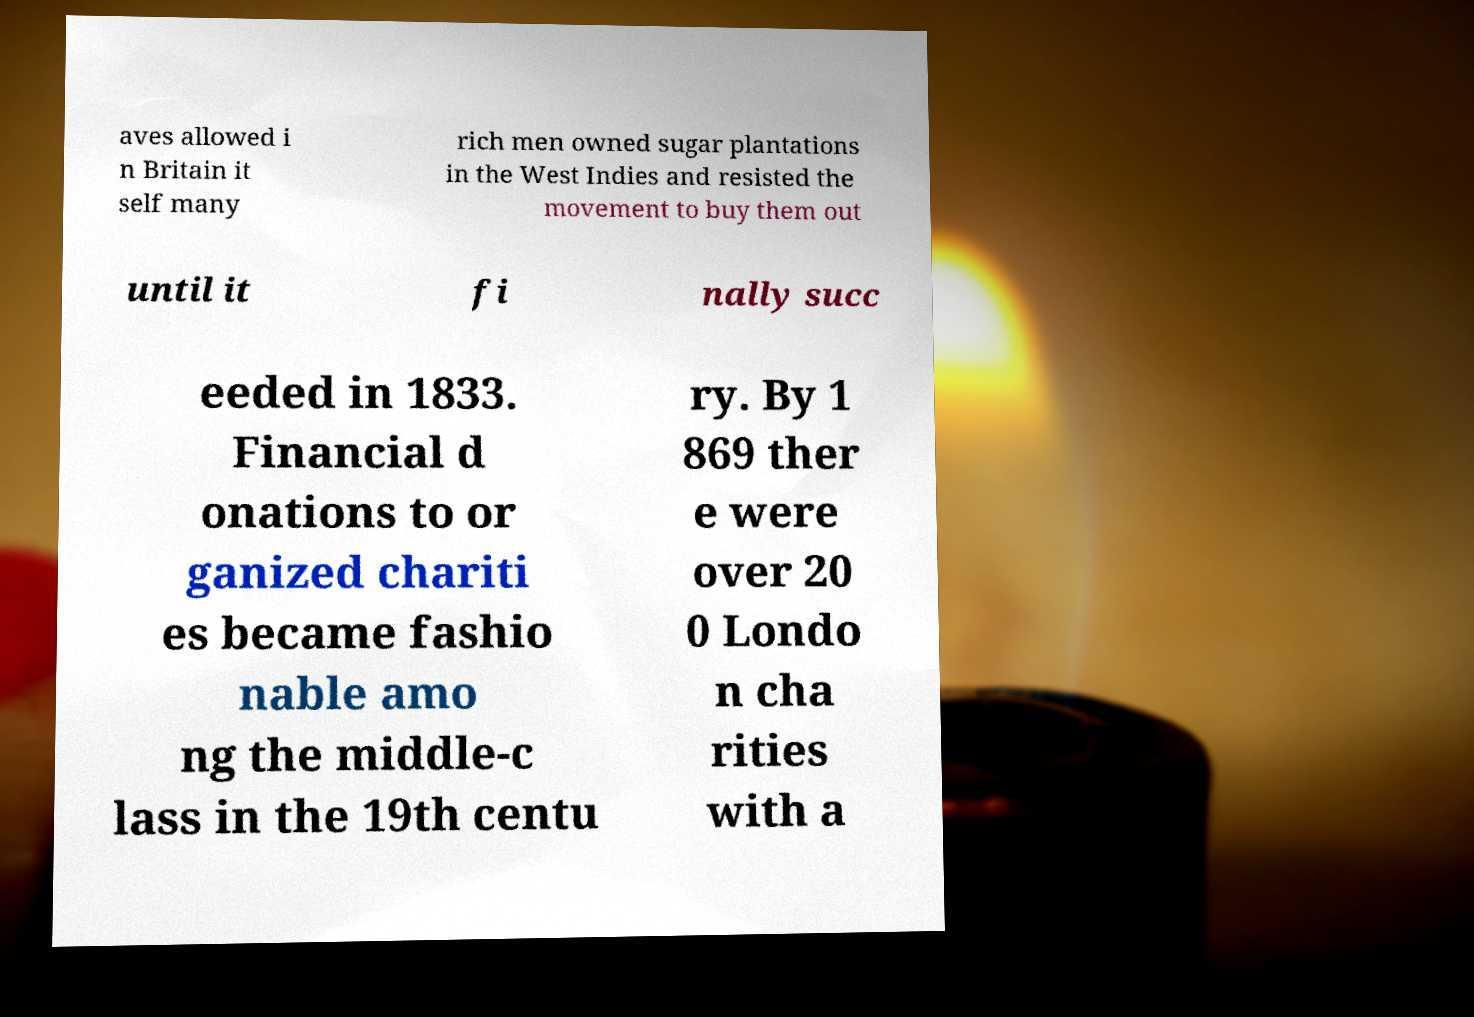What messages or text are displayed in this image? I need them in a readable, typed format. aves allowed i n Britain it self many rich men owned sugar plantations in the West Indies and resisted the movement to buy them out until it fi nally succ eeded in 1833. Financial d onations to or ganized chariti es became fashio nable amo ng the middle-c lass in the 19th centu ry. By 1 869 ther e were over 20 0 Londo n cha rities with a 